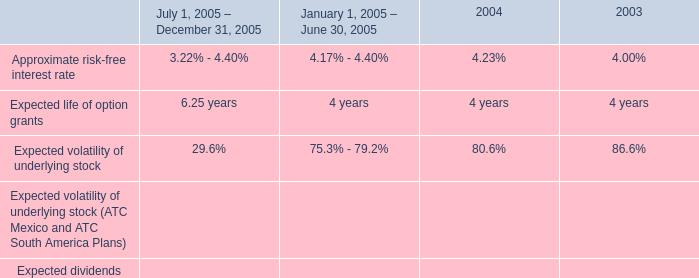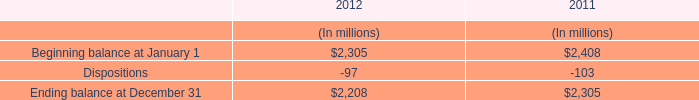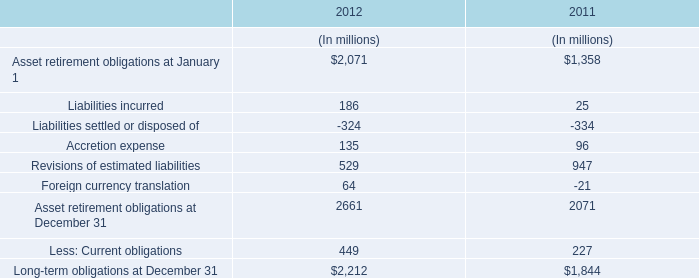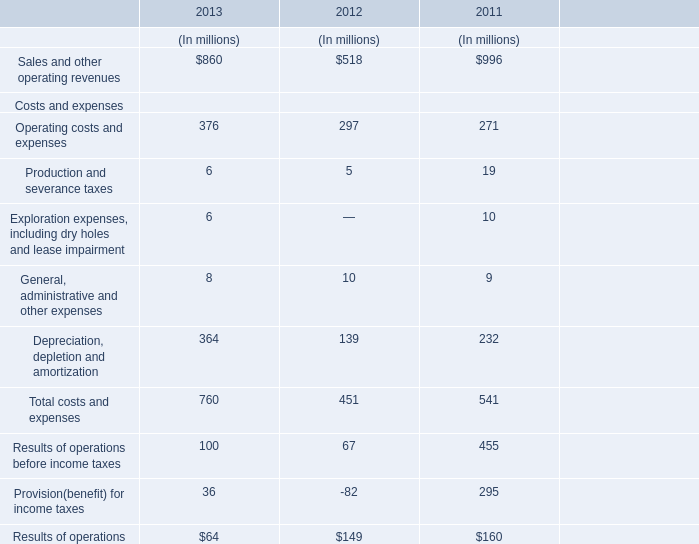what are the total proceeds from the issuance of employee options during february 2004 , in millions? 
Computations: ((1032717 * 11.19) / 1000000)
Answer: 11.5561. 